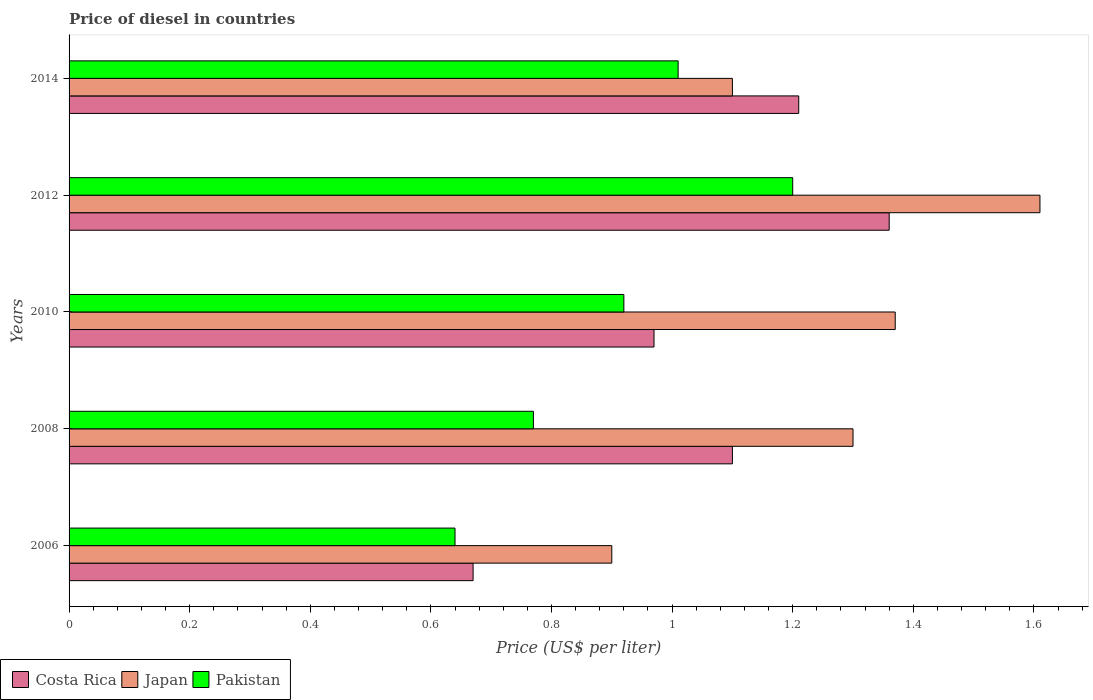How many different coloured bars are there?
Make the answer very short. 3. Are the number of bars on each tick of the Y-axis equal?
Your response must be concise. Yes. In how many cases, is the number of bars for a given year not equal to the number of legend labels?
Give a very brief answer. 0. Across all years, what is the maximum price of diesel in Japan?
Provide a succinct answer. 1.61. In which year was the price of diesel in Pakistan maximum?
Keep it short and to the point. 2012. What is the total price of diesel in Costa Rica in the graph?
Provide a succinct answer. 5.31. What is the difference between the price of diesel in Japan in 2006 and that in 2010?
Your answer should be compact. -0.47. What is the difference between the price of diesel in Japan in 2010 and the price of diesel in Pakistan in 2008?
Your answer should be compact. 0.6. What is the average price of diesel in Pakistan per year?
Your answer should be compact. 0.91. In the year 2014, what is the difference between the price of diesel in Japan and price of diesel in Pakistan?
Offer a very short reply. 0.09. What is the ratio of the price of diesel in Costa Rica in 2008 to that in 2014?
Offer a terse response. 0.91. What is the difference between the highest and the second highest price of diesel in Pakistan?
Offer a very short reply. 0.19. What is the difference between the highest and the lowest price of diesel in Japan?
Give a very brief answer. 0.71. Is it the case that in every year, the sum of the price of diesel in Japan and price of diesel in Costa Rica is greater than the price of diesel in Pakistan?
Your answer should be very brief. Yes. How many bars are there?
Keep it short and to the point. 15. Are all the bars in the graph horizontal?
Ensure brevity in your answer.  Yes. What is the difference between two consecutive major ticks on the X-axis?
Keep it short and to the point. 0.2. Where does the legend appear in the graph?
Ensure brevity in your answer.  Bottom left. How are the legend labels stacked?
Provide a short and direct response. Horizontal. What is the title of the graph?
Make the answer very short. Price of diesel in countries. What is the label or title of the X-axis?
Your response must be concise. Price (US$ per liter). What is the Price (US$ per liter) of Costa Rica in 2006?
Provide a succinct answer. 0.67. What is the Price (US$ per liter) of Pakistan in 2006?
Your answer should be compact. 0.64. What is the Price (US$ per liter) in Pakistan in 2008?
Provide a short and direct response. 0.77. What is the Price (US$ per liter) in Costa Rica in 2010?
Your answer should be compact. 0.97. What is the Price (US$ per liter) in Japan in 2010?
Keep it short and to the point. 1.37. What is the Price (US$ per liter) in Pakistan in 2010?
Your answer should be very brief. 0.92. What is the Price (US$ per liter) in Costa Rica in 2012?
Your answer should be very brief. 1.36. What is the Price (US$ per liter) of Japan in 2012?
Provide a succinct answer. 1.61. What is the Price (US$ per liter) of Pakistan in 2012?
Provide a short and direct response. 1.2. What is the Price (US$ per liter) of Costa Rica in 2014?
Your answer should be very brief. 1.21. What is the Price (US$ per liter) in Japan in 2014?
Your response must be concise. 1.1. Across all years, what is the maximum Price (US$ per liter) of Costa Rica?
Give a very brief answer. 1.36. Across all years, what is the maximum Price (US$ per liter) of Japan?
Make the answer very short. 1.61. Across all years, what is the maximum Price (US$ per liter) in Pakistan?
Your response must be concise. 1.2. Across all years, what is the minimum Price (US$ per liter) in Costa Rica?
Give a very brief answer. 0.67. Across all years, what is the minimum Price (US$ per liter) in Pakistan?
Provide a succinct answer. 0.64. What is the total Price (US$ per liter) in Costa Rica in the graph?
Your answer should be very brief. 5.31. What is the total Price (US$ per liter) in Japan in the graph?
Provide a succinct answer. 6.28. What is the total Price (US$ per liter) of Pakistan in the graph?
Offer a terse response. 4.54. What is the difference between the Price (US$ per liter) of Costa Rica in 2006 and that in 2008?
Offer a very short reply. -0.43. What is the difference between the Price (US$ per liter) in Pakistan in 2006 and that in 2008?
Keep it short and to the point. -0.13. What is the difference between the Price (US$ per liter) in Japan in 2006 and that in 2010?
Make the answer very short. -0.47. What is the difference between the Price (US$ per liter) of Pakistan in 2006 and that in 2010?
Provide a short and direct response. -0.28. What is the difference between the Price (US$ per liter) in Costa Rica in 2006 and that in 2012?
Make the answer very short. -0.69. What is the difference between the Price (US$ per liter) in Japan in 2006 and that in 2012?
Provide a succinct answer. -0.71. What is the difference between the Price (US$ per liter) in Pakistan in 2006 and that in 2012?
Provide a succinct answer. -0.56. What is the difference between the Price (US$ per liter) in Costa Rica in 2006 and that in 2014?
Keep it short and to the point. -0.54. What is the difference between the Price (US$ per liter) in Japan in 2006 and that in 2014?
Offer a terse response. -0.2. What is the difference between the Price (US$ per liter) in Pakistan in 2006 and that in 2014?
Your answer should be compact. -0.37. What is the difference between the Price (US$ per liter) in Costa Rica in 2008 and that in 2010?
Keep it short and to the point. 0.13. What is the difference between the Price (US$ per liter) of Japan in 2008 and that in 2010?
Offer a terse response. -0.07. What is the difference between the Price (US$ per liter) in Costa Rica in 2008 and that in 2012?
Make the answer very short. -0.26. What is the difference between the Price (US$ per liter) of Japan in 2008 and that in 2012?
Your response must be concise. -0.31. What is the difference between the Price (US$ per liter) of Pakistan in 2008 and that in 2012?
Ensure brevity in your answer.  -0.43. What is the difference between the Price (US$ per liter) of Costa Rica in 2008 and that in 2014?
Provide a succinct answer. -0.11. What is the difference between the Price (US$ per liter) of Japan in 2008 and that in 2014?
Offer a very short reply. 0.2. What is the difference between the Price (US$ per liter) in Pakistan in 2008 and that in 2014?
Offer a very short reply. -0.24. What is the difference between the Price (US$ per liter) of Costa Rica in 2010 and that in 2012?
Ensure brevity in your answer.  -0.39. What is the difference between the Price (US$ per liter) of Japan in 2010 and that in 2012?
Provide a succinct answer. -0.24. What is the difference between the Price (US$ per liter) of Pakistan in 2010 and that in 2012?
Your response must be concise. -0.28. What is the difference between the Price (US$ per liter) of Costa Rica in 2010 and that in 2014?
Provide a succinct answer. -0.24. What is the difference between the Price (US$ per liter) in Japan in 2010 and that in 2014?
Offer a very short reply. 0.27. What is the difference between the Price (US$ per liter) in Pakistan in 2010 and that in 2014?
Offer a terse response. -0.09. What is the difference between the Price (US$ per liter) in Japan in 2012 and that in 2014?
Your answer should be very brief. 0.51. What is the difference between the Price (US$ per liter) of Pakistan in 2012 and that in 2014?
Offer a terse response. 0.19. What is the difference between the Price (US$ per liter) in Costa Rica in 2006 and the Price (US$ per liter) in Japan in 2008?
Keep it short and to the point. -0.63. What is the difference between the Price (US$ per liter) in Costa Rica in 2006 and the Price (US$ per liter) in Pakistan in 2008?
Keep it short and to the point. -0.1. What is the difference between the Price (US$ per liter) in Japan in 2006 and the Price (US$ per liter) in Pakistan in 2008?
Offer a very short reply. 0.13. What is the difference between the Price (US$ per liter) of Japan in 2006 and the Price (US$ per liter) of Pakistan in 2010?
Keep it short and to the point. -0.02. What is the difference between the Price (US$ per liter) of Costa Rica in 2006 and the Price (US$ per liter) of Japan in 2012?
Provide a succinct answer. -0.94. What is the difference between the Price (US$ per liter) in Costa Rica in 2006 and the Price (US$ per liter) in Pakistan in 2012?
Make the answer very short. -0.53. What is the difference between the Price (US$ per liter) of Japan in 2006 and the Price (US$ per liter) of Pakistan in 2012?
Provide a succinct answer. -0.3. What is the difference between the Price (US$ per liter) in Costa Rica in 2006 and the Price (US$ per liter) in Japan in 2014?
Offer a terse response. -0.43. What is the difference between the Price (US$ per liter) in Costa Rica in 2006 and the Price (US$ per liter) in Pakistan in 2014?
Your response must be concise. -0.34. What is the difference between the Price (US$ per liter) of Japan in 2006 and the Price (US$ per liter) of Pakistan in 2014?
Make the answer very short. -0.11. What is the difference between the Price (US$ per liter) in Costa Rica in 2008 and the Price (US$ per liter) in Japan in 2010?
Keep it short and to the point. -0.27. What is the difference between the Price (US$ per liter) in Costa Rica in 2008 and the Price (US$ per liter) in Pakistan in 2010?
Keep it short and to the point. 0.18. What is the difference between the Price (US$ per liter) of Japan in 2008 and the Price (US$ per liter) of Pakistan in 2010?
Offer a very short reply. 0.38. What is the difference between the Price (US$ per liter) in Costa Rica in 2008 and the Price (US$ per liter) in Japan in 2012?
Ensure brevity in your answer.  -0.51. What is the difference between the Price (US$ per liter) of Costa Rica in 2008 and the Price (US$ per liter) of Pakistan in 2012?
Keep it short and to the point. -0.1. What is the difference between the Price (US$ per liter) in Costa Rica in 2008 and the Price (US$ per liter) in Pakistan in 2014?
Offer a terse response. 0.09. What is the difference between the Price (US$ per liter) in Japan in 2008 and the Price (US$ per liter) in Pakistan in 2014?
Offer a terse response. 0.29. What is the difference between the Price (US$ per liter) in Costa Rica in 2010 and the Price (US$ per liter) in Japan in 2012?
Make the answer very short. -0.64. What is the difference between the Price (US$ per liter) in Costa Rica in 2010 and the Price (US$ per liter) in Pakistan in 2012?
Offer a terse response. -0.23. What is the difference between the Price (US$ per liter) in Japan in 2010 and the Price (US$ per liter) in Pakistan in 2012?
Offer a very short reply. 0.17. What is the difference between the Price (US$ per liter) of Costa Rica in 2010 and the Price (US$ per liter) of Japan in 2014?
Make the answer very short. -0.13. What is the difference between the Price (US$ per liter) of Costa Rica in 2010 and the Price (US$ per liter) of Pakistan in 2014?
Your response must be concise. -0.04. What is the difference between the Price (US$ per liter) of Japan in 2010 and the Price (US$ per liter) of Pakistan in 2014?
Provide a succinct answer. 0.36. What is the difference between the Price (US$ per liter) of Costa Rica in 2012 and the Price (US$ per liter) of Japan in 2014?
Ensure brevity in your answer.  0.26. What is the difference between the Price (US$ per liter) of Costa Rica in 2012 and the Price (US$ per liter) of Pakistan in 2014?
Offer a very short reply. 0.35. What is the difference between the Price (US$ per liter) of Japan in 2012 and the Price (US$ per liter) of Pakistan in 2014?
Make the answer very short. 0.6. What is the average Price (US$ per liter) in Costa Rica per year?
Offer a terse response. 1.06. What is the average Price (US$ per liter) in Japan per year?
Give a very brief answer. 1.26. What is the average Price (US$ per liter) of Pakistan per year?
Give a very brief answer. 0.91. In the year 2006, what is the difference between the Price (US$ per liter) of Costa Rica and Price (US$ per liter) of Japan?
Provide a succinct answer. -0.23. In the year 2006, what is the difference between the Price (US$ per liter) of Costa Rica and Price (US$ per liter) of Pakistan?
Provide a succinct answer. 0.03. In the year 2006, what is the difference between the Price (US$ per liter) in Japan and Price (US$ per liter) in Pakistan?
Make the answer very short. 0.26. In the year 2008, what is the difference between the Price (US$ per liter) in Costa Rica and Price (US$ per liter) in Pakistan?
Offer a terse response. 0.33. In the year 2008, what is the difference between the Price (US$ per liter) in Japan and Price (US$ per liter) in Pakistan?
Your answer should be compact. 0.53. In the year 2010, what is the difference between the Price (US$ per liter) in Japan and Price (US$ per liter) in Pakistan?
Make the answer very short. 0.45. In the year 2012, what is the difference between the Price (US$ per liter) in Costa Rica and Price (US$ per liter) in Japan?
Make the answer very short. -0.25. In the year 2012, what is the difference between the Price (US$ per liter) of Costa Rica and Price (US$ per liter) of Pakistan?
Keep it short and to the point. 0.16. In the year 2012, what is the difference between the Price (US$ per liter) in Japan and Price (US$ per liter) in Pakistan?
Ensure brevity in your answer.  0.41. In the year 2014, what is the difference between the Price (US$ per liter) in Costa Rica and Price (US$ per liter) in Japan?
Ensure brevity in your answer.  0.11. In the year 2014, what is the difference between the Price (US$ per liter) in Japan and Price (US$ per liter) in Pakistan?
Give a very brief answer. 0.09. What is the ratio of the Price (US$ per liter) of Costa Rica in 2006 to that in 2008?
Your answer should be very brief. 0.61. What is the ratio of the Price (US$ per liter) in Japan in 2006 to that in 2008?
Your response must be concise. 0.69. What is the ratio of the Price (US$ per liter) in Pakistan in 2006 to that in 2008?
Offer a very short reply. 0.83. What is the ratio of the Price (US$ per liter) of Costa Rica in 2006 to that in 2010?
Your response must be concise. 0.69. What is the ratio of the Price (US$ per liter) of Japan in 2006 to that in 2010?
Ensure brevity in your answer.  0.66. What is the ratio of the Price (US$ per liter) of Pakistan in 2006 to that in 2010?
Your answer should be very brief. 0.7. What is the ratio of the Price (US$ per liter) in Costa Rica in 2006 to that in 2012?
Make the answer very short. 0.49. What is the ratio of the Price (US$ per liter) in Japan in 2006 to that in 2012?
Give a very brief answer. 0.56. What is the ratio of the Price (US$ per liter) of Pakistan in 2006 to that in 2012?
Your response must be concise. 0.53. What is the ratio of the Price (US$ per liter) of Costa Rica in 2006 to that in 2014?
Ensure brevity in your answer.  0.55. What is the ratio of the Price (US$ per liter) in Japan in 2006 to that in 2014?
Offer a terse response. 0.82. What is the ratio of the Price (US$ per liter) in Pakistan in 2006 to that in 2014?
Provide a short and direct response. 0.63. What is the ratio of the Price (US$ per liter) in Costa Rica in 2008 to that in 2010?
Your response must be concise. 1.13. What is the ratio of the Price (US$ per liter) in Japan in 2008 to that in 2010?
Keep it short and to the point. 0.95. What is the ratio of the Price (US$ per liter) of Pakistan in 2008 to that in 2010?
Provide a succinct answer. 0.84. What is the ratio of the Price (US$ per liter) in Costa Rica in 2008 to that in 2012?
Provide a succinct answer. 0.81. What is the ratio of the Price (US$ per liter) in Japan in 2008 to that in 2012?
Offer a very short reply. 0.81. What is the ratio of the Price (US$ per liter) of Pakistan in 2008 to that in 2012?
Offer a very short reply. 0.64. What is the ratio of the Price (US$ per liter) in Costa Rica in 2008 to that in 2014?
Offer a very short reply. 0.91. What is the ratio of the Price (US$ per liter) of Japan in 2008 to that in 2014?
Make the answer very short. 1.18. What is the ratio of the Price (US$ per liter) of Pakistan in 2008 to that in 2014?
Provide a short and direct response. 0.76. What is the ratio of the Price (US$ per liter) of Costa Rica in 2010 to that in 2012?
Make the answer very short. 0.71. What is the ratio of the Price (US$ per liter) in Japan in 2010 to that in 2012?
Your answer should be very brief. 0.85. What is the ratio of the Price (US$ per liter) of Pakistan in 2010 to that in 2012?
Make the answer very short. 0.77. What is the ratio of the Price (US$ per liter) in Costa Rica in 2010 to that in 2014?
Provide a succinct answer. 0.8. What is the ratio of the Price (US$ per liter) of Japan in 2010 to that in 2014?
Give a very brief answer. 1.25. What is the ratio of the Price (US$ per liter) in Pakistan in 2010 to that in 2014?
Keep it short and to the point. 0.91. What is the ratio of the Price (US$ per liter) in Costa Rica in 2012 to that in 2014?
Your answer should be compact. 1.12. What is the ratio of the Price (US$ per liter) of Japan in 2012 to that in 2014?
Offer a very short reply. 1.46. What is the ratio of the Price (US$ per liter) in Pakistan in 2012 to that in 2014?
Provide a succinct answer. 1.19. What is the difference between the highest and the second highest Price (US$ per liter) in Japan?
Your answer should be very brief. 0.24. What is the difference between the highest and the second highest Price (US$ per liter) in Pakistan?
Offer a very short reply. 0.19. What is the difference between the highest and the lowest Price (US$ per liter) of Costa Rica?
Give a very brief answer. 0.69. What is the difference between the highest and the lowest Price (US$ per liter) of Japan?
Make the answer very short. 0.71. What is the difference between the highest and the lowest Price (US$ per liter) in Pakistan?
Make the answer very short. 0.56. 